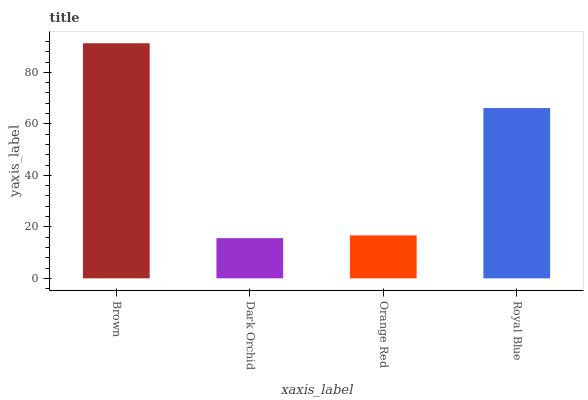Is Dark Orchid the minimum?
Answer yes or no. Yes. Is Brown the maximum?
Answer yes or no. Yes. Is Orange Red the minimum?
Answer yes or no. No. Is Orange Red the maximum?
Answer yes or no. No. Is Orange Red greater than Dark Orchid?
Answer yes or no. Yes. Is Dark Orchid less than Orange Red?
Answer yes or no. Yes. Is Dark Orchid greater than Orange Red?
Answer yes or no. No. Is Orange Red less than Dark Orchid?
Answer yes or no. No. Is Royal Blue the high median?
Answer yes or no. Yes. Is Orange Red the low median?
Answer yes or no. Yes. Is Brown the high median?
Answer yes or no. No. Is Dark Orchid the low median?
Answer yes or no. No. 